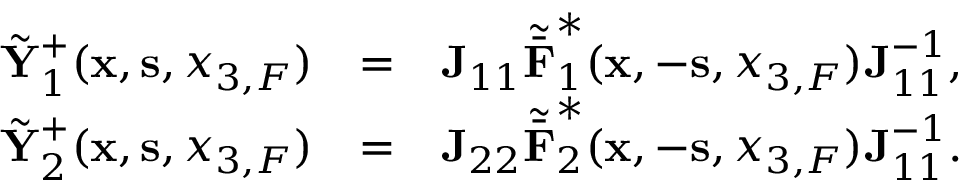Convert formula to latex. <formula><loc_0><loc_0><loc_500><loc_500>\begin{array} { r l r } { \tilde { Y } _ { 1 } ^ { + } ( { x } , { s } , { x _ { 3 , F } } ) } & { = } & { { J } _ { 1 1 } { \tilde { \bar { F } } } _ { 1 } ^ { * } ( { x } , - { s } , { x _ { 3 , F } } ) { J } _ { 1 1 } ^ { - 1 } , } \\ { \tilde { Y } _ { 2 } ^ { + } ( { x } , { s } , { x _ { 3 , F } } ) } & { = } & { { J } _ { 2 2 } { \tilde { \bar { F } } } _ { 2 } ^ { * } ( { x } , - { s } , { x _ { 3 , F } } ) { J } _ { 1 1 } ^ { - 1 } . } \end{array}</formula> 